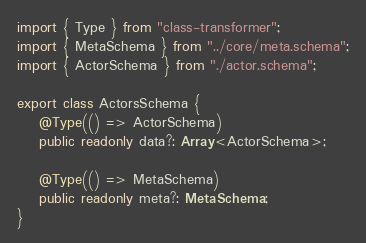Convert code to text. <code><loc_0><loc_0><loc_500><loc_500><_TypeScript_>import { Type } from "class-transformer";
import { MetaSchema } from "../core/meta.schema";
import { ActorSchema } from "./actor.schema";

export class ActorsSchema {
    @Type(() => ActorSchema)
    public readonly data?: Array<ActorSchema>;

    @Type(() => MetaSchema)
    public readonly meta?: MetaSchema;
}





</code> 